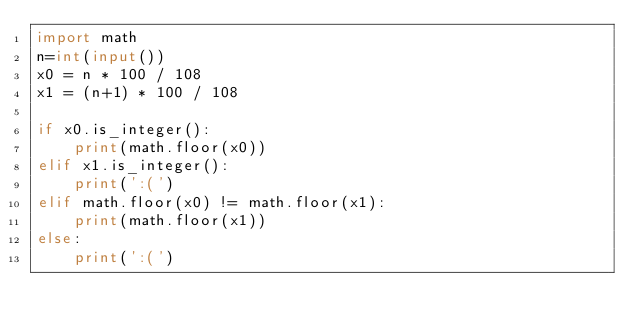Convert code to text. <code><loc_0><loc_0><loc_500><loc_500><_Python_>import math
n=int(input())
x0 = n * 100 / 108
x1 = (n+1) * 100 / 108

if x0.is_integer():
    print(math.floor(x0))
elif x1.is_integer():
    print(':(')
elif math.floor(x0) != math.floor(x1):
    print(math.floor(x1))
else:
    print(':(')
</code> 